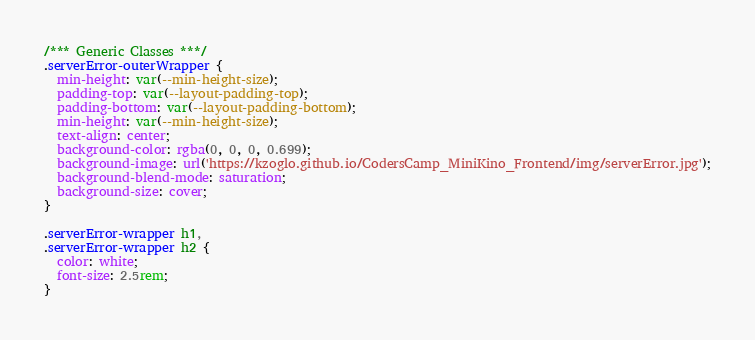Convert code to text. <code><loc_0><loc_0><loc_500><loc_500><_CSS_>/*** Generic Classes ***/
.serverError-outerWrapper {
  min-height: var(--min-height-size);
  padding-top: var(--layout-padding-top);
  padding-bottom: var(--layout-padding-bottom);
  min-height: var(--min-height-size);
  text-align: center;
  background-color: rgba(0, 0, 0, 0.699);
  background-image: url('https://kzoglo.github.io/CodersCamp_MiniKino_Frontend/img/serverError.jpg');
  background-blend-mode: saturation;
  background-size: cover;
}

.serverError-wrapper h1,
.serverError-wrapper h2 {
  color: white;
  font-size: 2.5rem;
}
</code> 